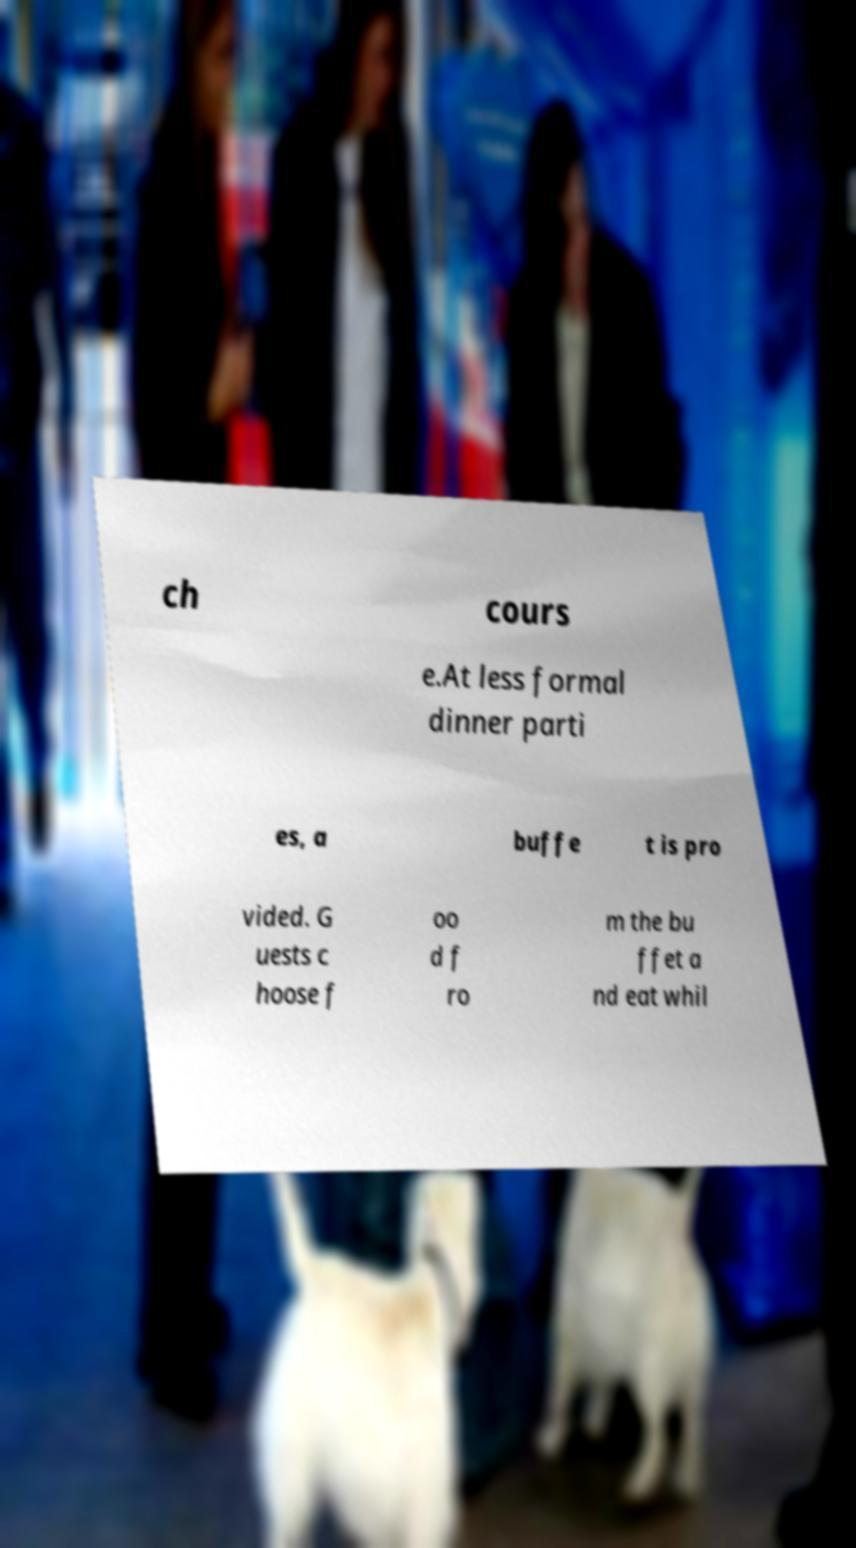For documentation purposes, I need the text within this image transcribed. Could you provide that? ch cours e.At less formal dinner parti es, a buffe t is pro vided. G uests c hoose f oo d f ro m the bu ffet a nd eat whil 